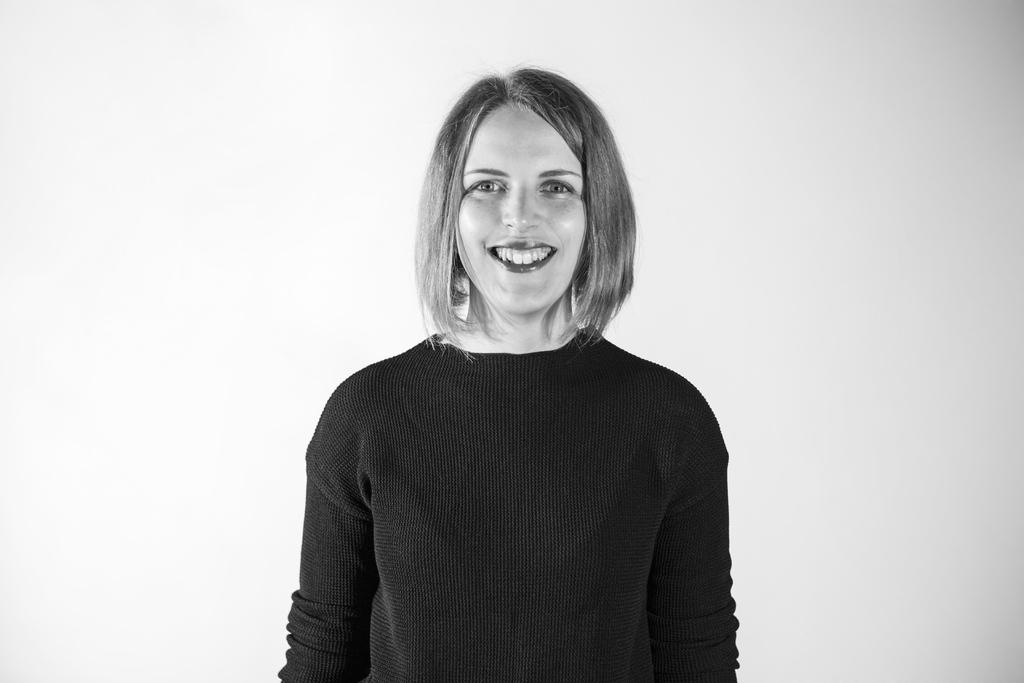What is the color scheme of the image? The image is black and white. Who is present in the image? There is a woman in the image. What is the woman doing in the image? The woman is smiling. What type of clothing is the woman wearing in the image? The woman is wearing a t-shirt. What type of tools does the woman have as a carpenter in the image? There is no indication in the image that the woman is a carpenter, nor are any tools visible. What is the woman doing on the moon in the image? There is no moon present in the image, and the woman is not depicted as being on the moon. 